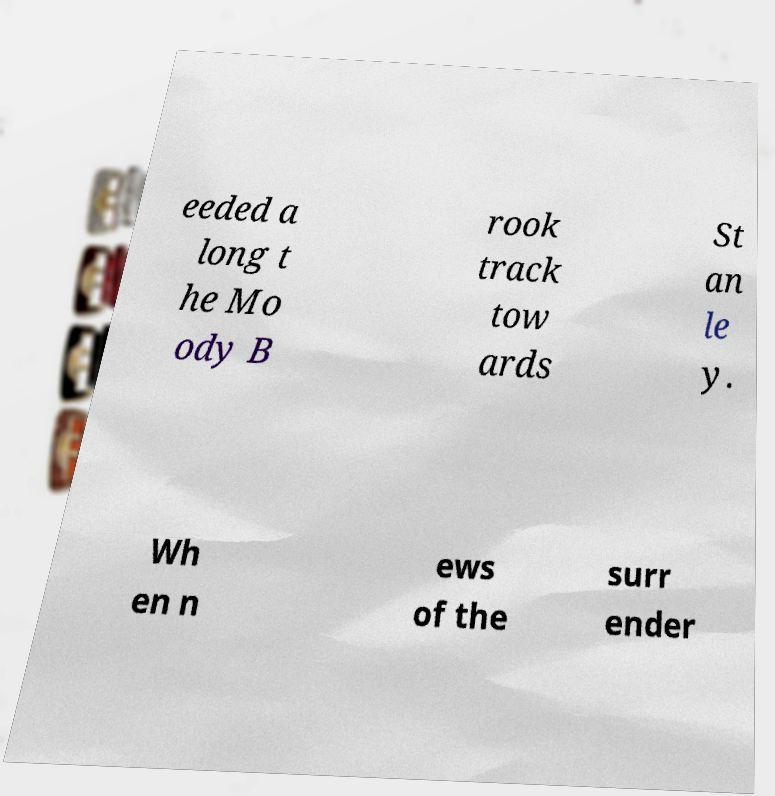Please identify and transcribe the text found in this image. eeded a long t he Mo ody B rook track tow ards St an le y. Wh en n ews of the surr ender 